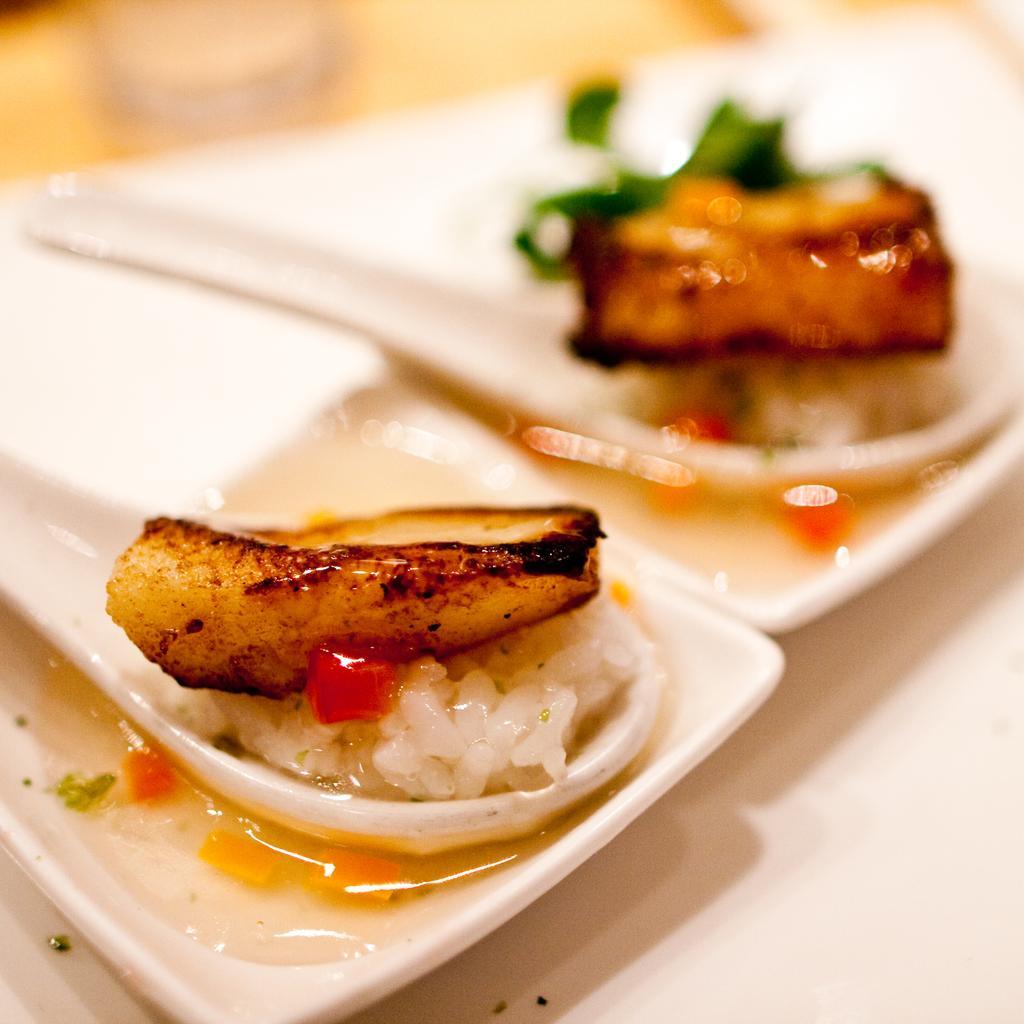Could you give a brief overview of what you see in this image? The picture consists of a table, on the table there are food items placed in plates. At the bottom it is table. At the top it is blurred. 